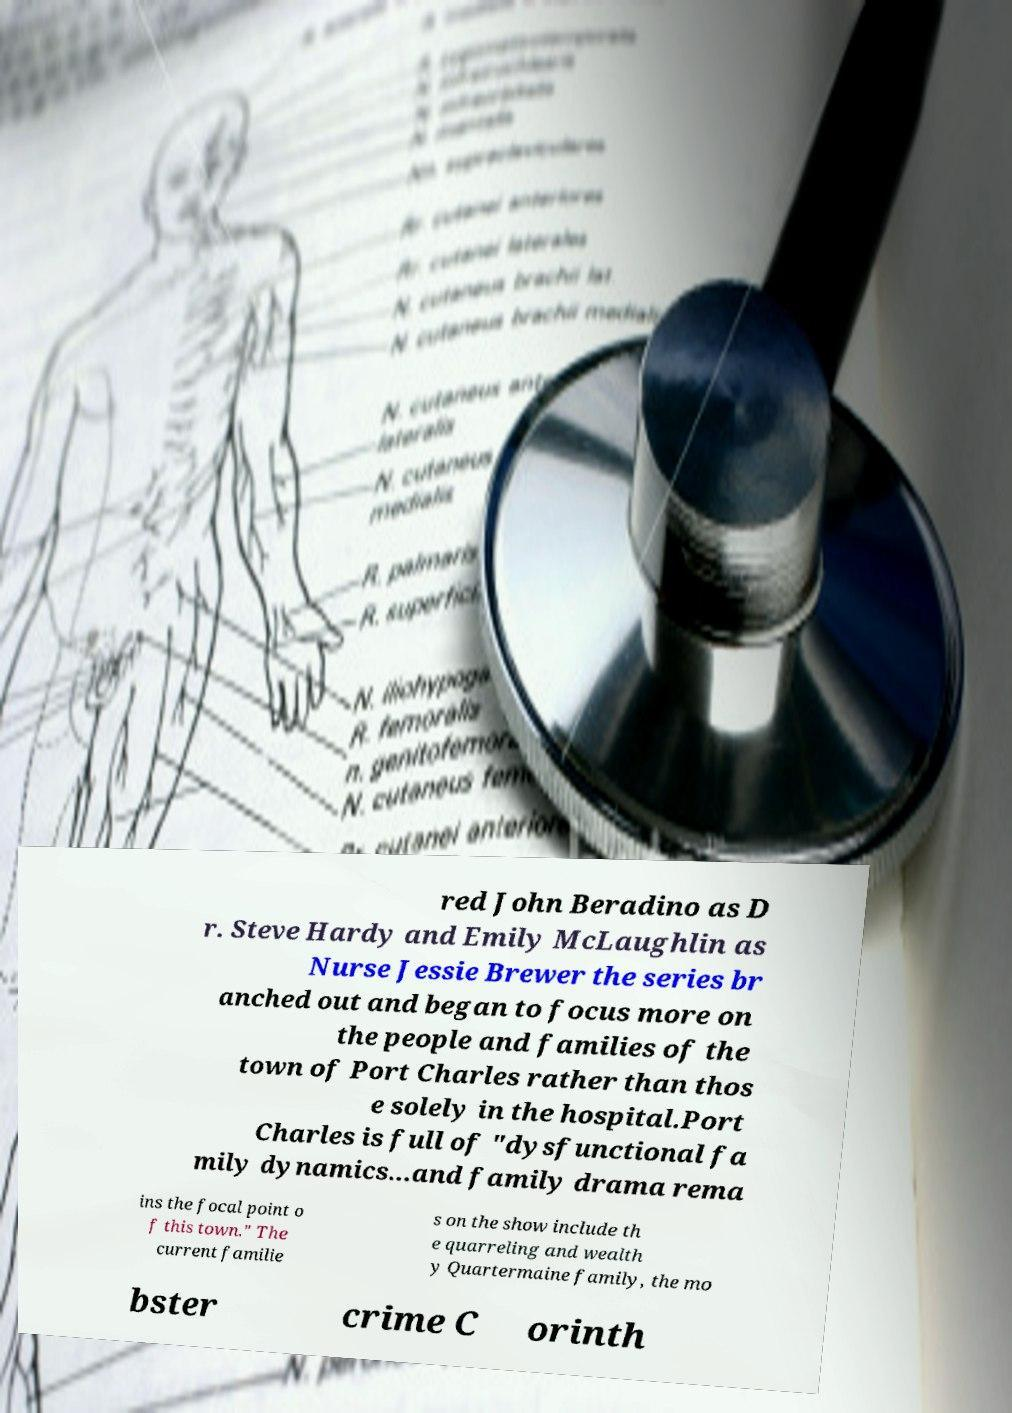For documentation purposes, I need the text within this image transcribed. Could you provide that? red John Beradino as D r. Steve Hardy and Emily McLaughlin as Nurse Jessie Brewer the series br anched out and began to focus more on the people and families of the town of Port Charles rather than thos e solely in the hospital.Port Charles is full of "dysfunctional fa mily dynamics...and family drama rema ins the focal point o f this town." The current familie s on the show include th e quarreling and wealth y Quartermaine family, the mo bster crime C orinth 